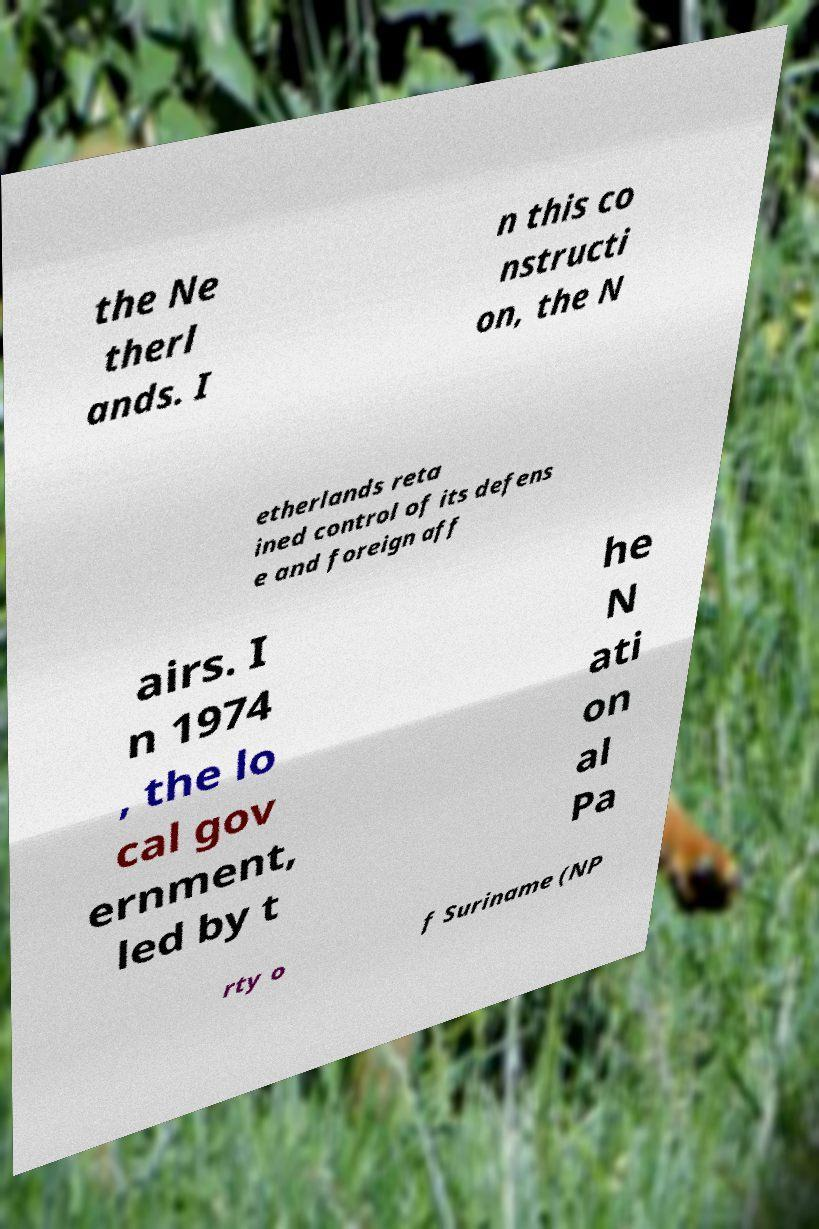Could you extract and type out the text from this image? the Ne therl ands. I n this co nstructi on, the N etherlands reta ined control of its defens e and foreign aff airs. I n 1974 , the lo cal gov ernment, led by t he N ati on al Pa rty o f Suriname (NP 